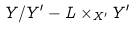Convert formula to latex. <formula><loc_0><loc_0><loc_500><loc_500>Y / Y ^ { \prime } - L \times _ { X ^ { \prime } } Y ^ { \prime }</formula> 